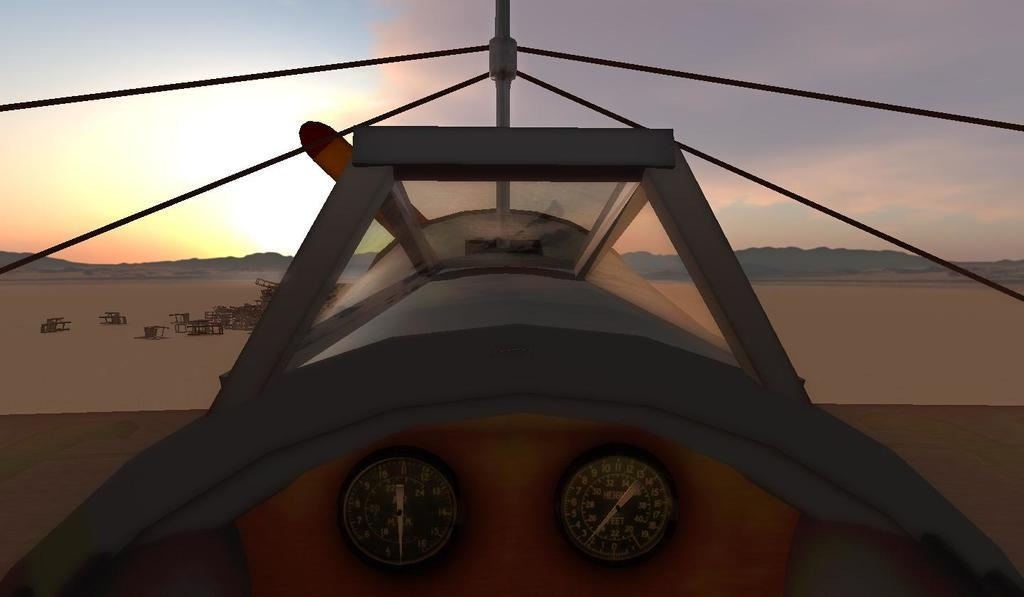<image>
Give a short and clear explanation of the subsequent image. The driver seat of a plane, which features a gauge for checking the height and feet. 